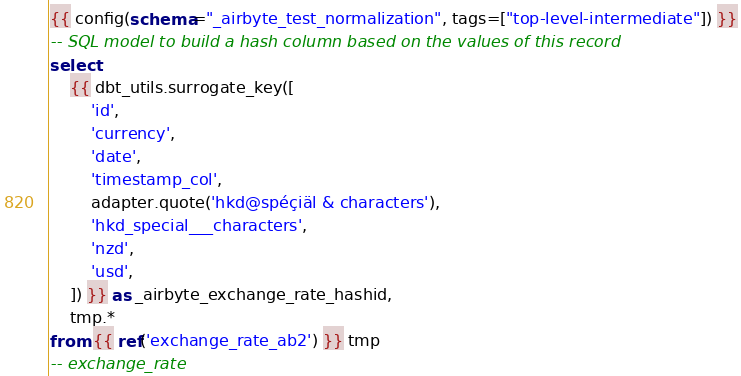Convert code to text. <code><loc_0><loc_0><loc_500><loc_500><_SQL_>{{ config(schema="_airbyte_test_normalization", tags=["top-level-intermediate"]) }}
-- SQL model to build a hash column based on the values of this record
select
    {{ dbt_utils.surrogate_key([
        'id',
        'currency',
        'date',
        'timestamp_col',
        adapter.quote('hkd@spéçiäl & characters'),
        'hkd_special___characters',
        'nzd',
        'usd',
    ]) }} as _airbyte_exchange_rate_hashid,
    tmp.*
from {{ ref('exchange_rate_ab2') }} tmp
-- exchange_rate

</code> 